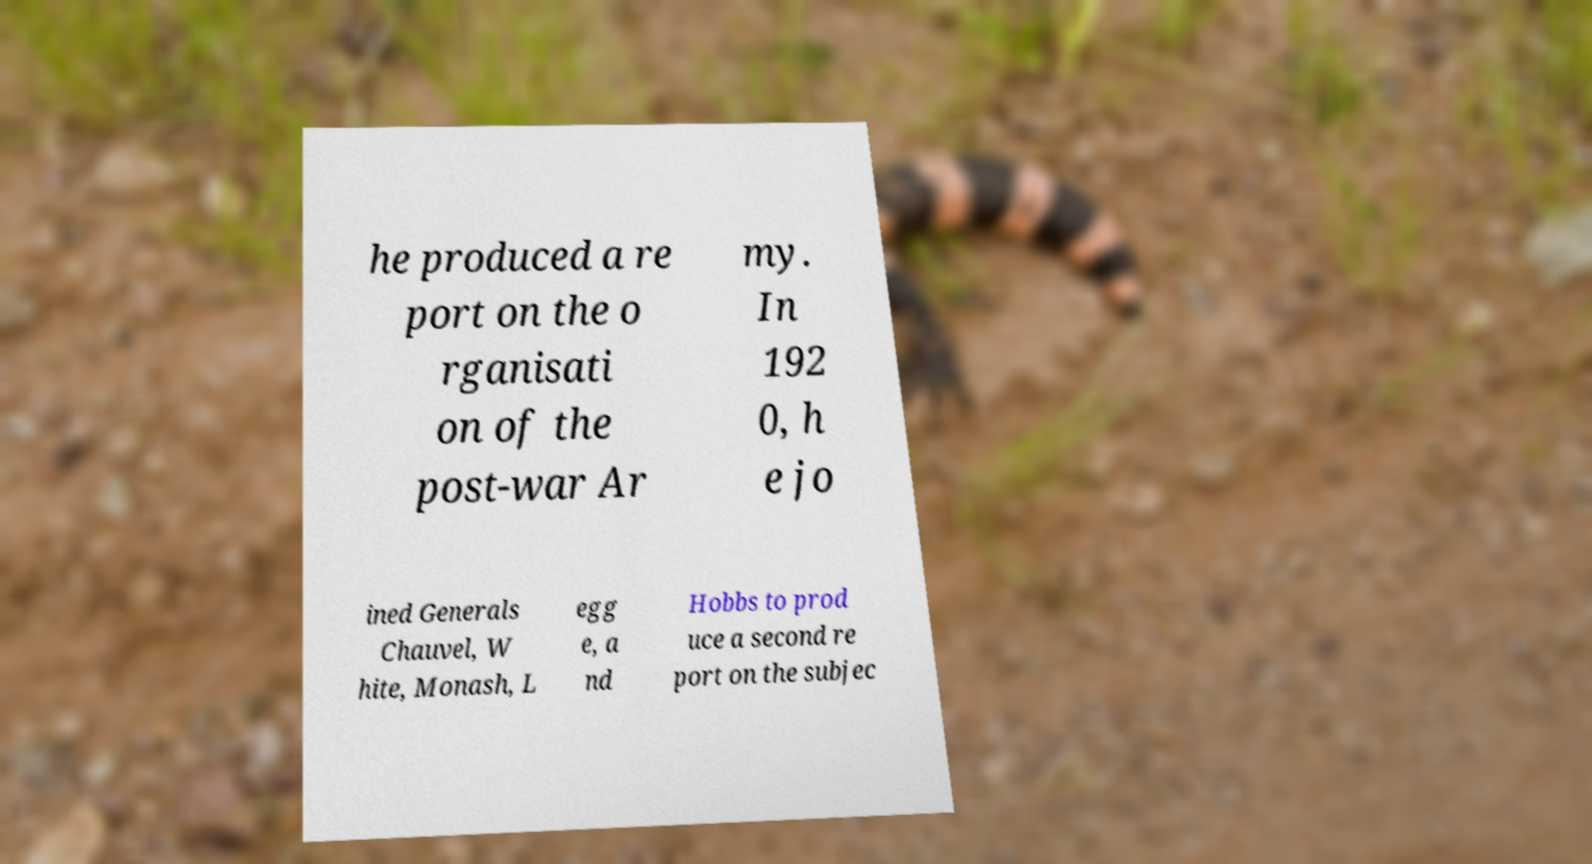There's text embedded in this image that I need extracted. Can you transcribe it verbatim? he produced a re port on the o rganisati on of the post-war Ar my. In 192 0, h e jo ined Generals Chauvel, W hite, Monash, L egg e, a nd Hobbs to prod uce a second re port on the subjec 